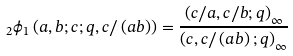Convert formula to latex. <formula><loc_0><loc_0><loc_500><loc_500>_ { 2 } \phi _ { 1 } \left ( a , b ; c ; q , c / \left ( a b \right ) \right ) = \frac { \left ( c / a , c / b ; q \right ) _ { \infty } } { \left ( c , c / \left ( a b \right ) ; q \right ) _ { \infty } }</formula> 